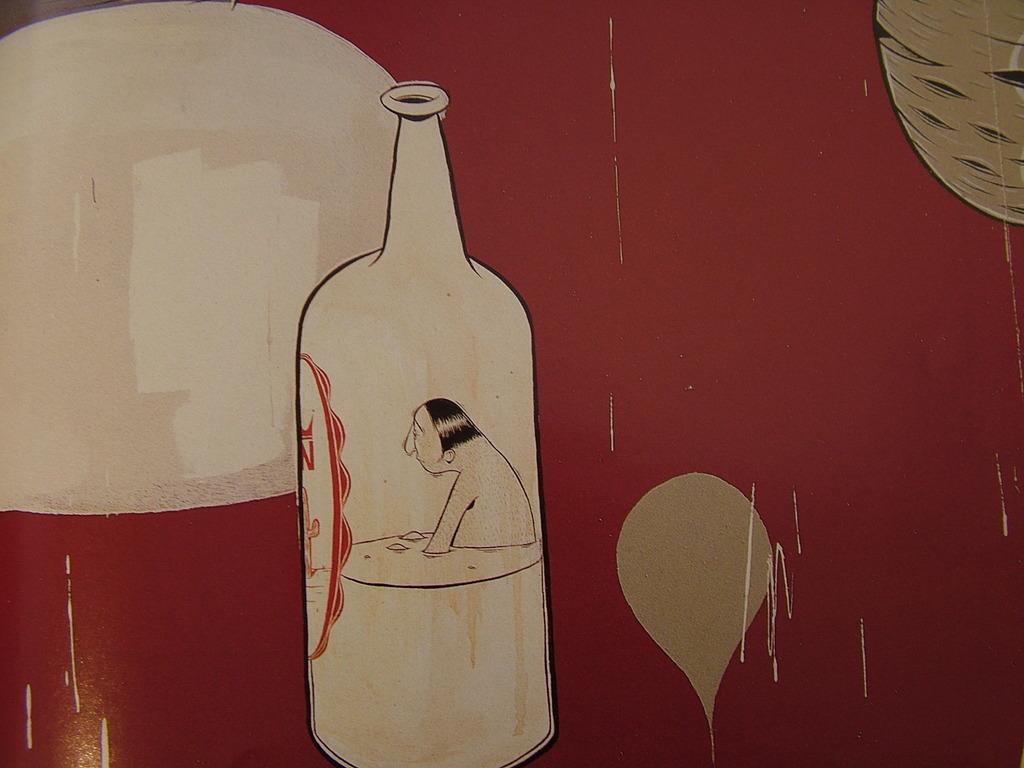What type of artwork is depicted in the image? The image is a drawing. What objects can be seen in the drawing? There is a bottle and a balloon in the drawing. Are there any living beings in the drawing? Yes, there is a person in the drawing. What color is the quince in the drawing? There is no quince present in the drawing. Does the person in the drawing have a tail? No, the person in the drawing does not have a tail. 